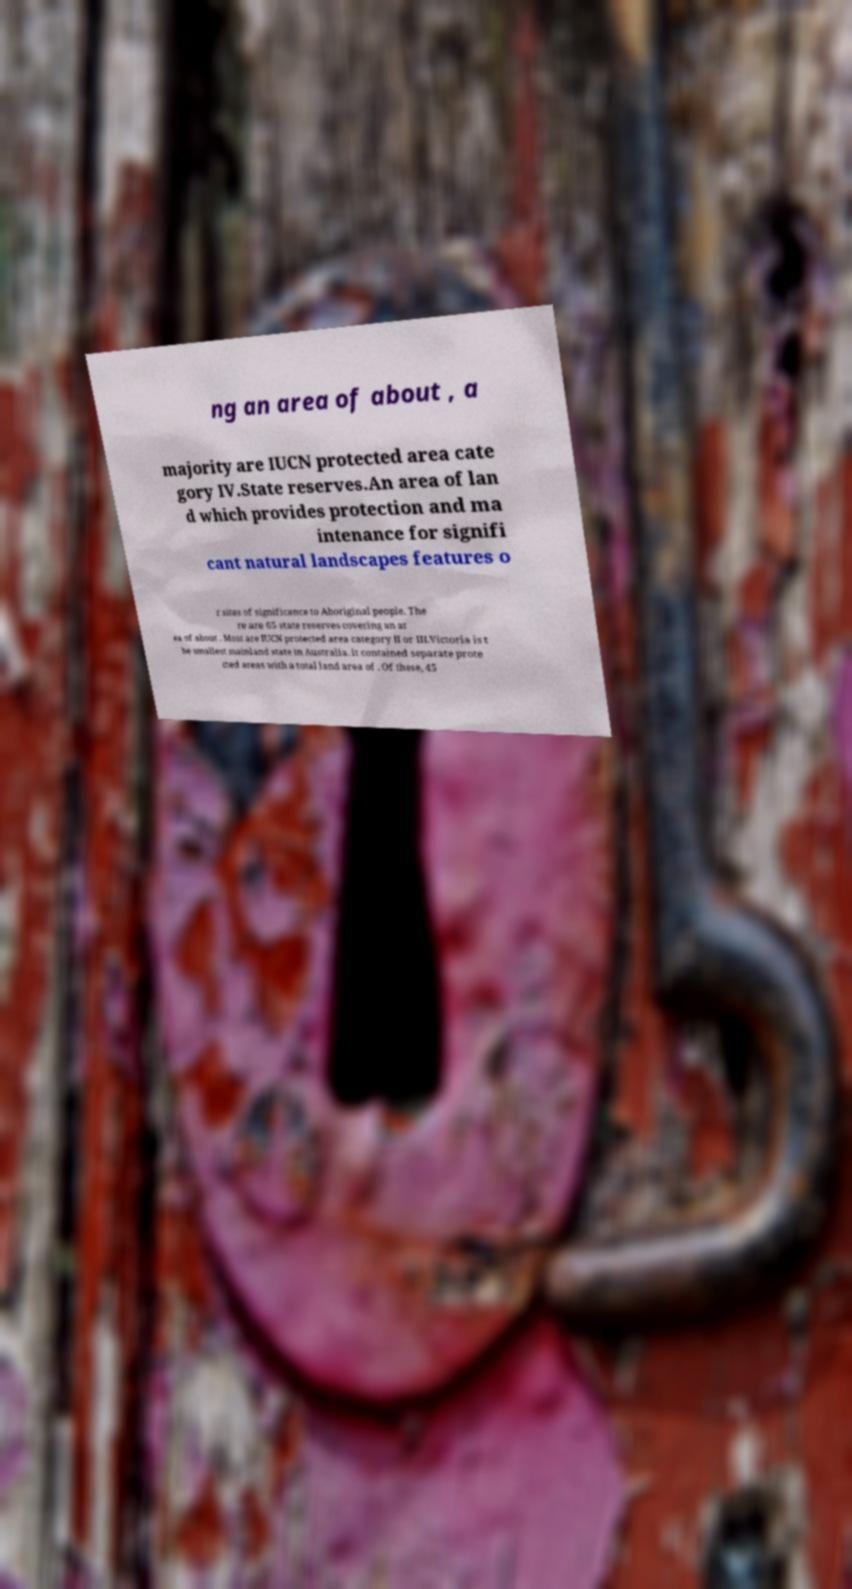I need the written content from this picture converted into text. Can you do that? ng an area of about , a majority are IUCN protected area cate gory IV.State reserves.An area of lan d which provides protection and ma intenance for signifi cant natural landscapes features o r sites of significance to Aboriginal people. The re are 65 state reserves covering an ar ea of about . Most are IUCN protected area category II or III.Victoria is t he smallest mainland state in Australia. it contained separate prote cted areas with a total land area of . Of these, 45 